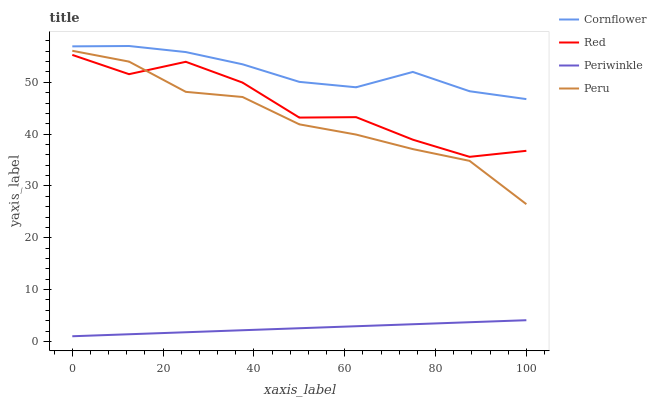Does Peru have the minimum area under the curve?
Answer yes or no. No. Does Peru have the maximum area under the curve?
Answer yes or no. No. Is Peru the smoothest?
Answer yes or no. No. Is Peru the roughest?
Answer yes or no. No. Does Peru have the lowest value?
Answer yes or no. No. Does Peru have the highest value?
Answer yes or no. No. Is Periwinkle less than Peru?
Answer yes or no. Yes. Is Cornflower greater than Red?
Answer yes or no. Yes. Does Periwinkle intersect Peru?
Answer yes or no. No. 